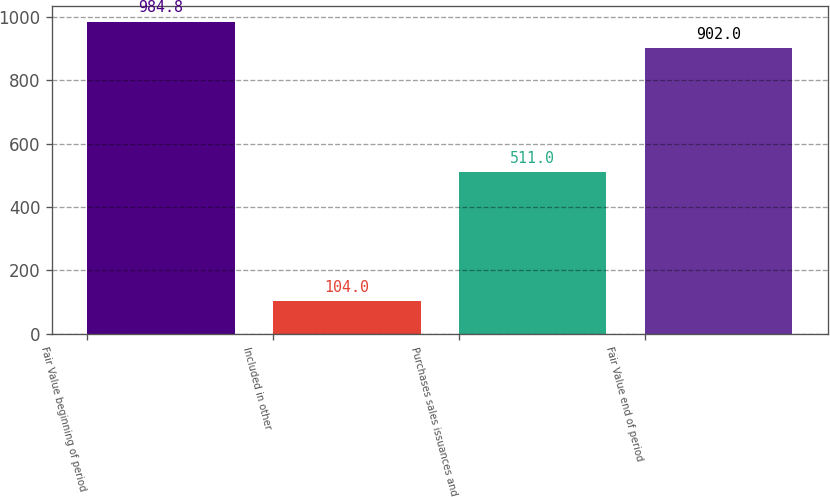Convert chart. <chart><loc_0><loc_0><loc_500><loc_500><bar_chart><fcel>Fair Value beginning of period<fcel>Included in other<fcel>Purchases sales issuances and<fcel>Fair Value end of period<nl><fcel>984.8<fcel>104<fcel>511<fcel>902<nl></chart> 